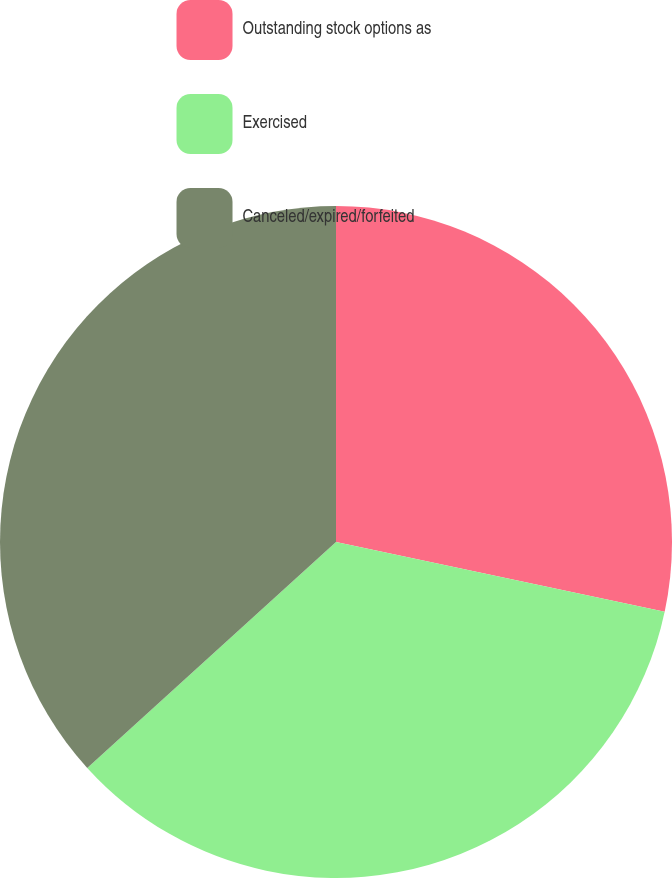<chart> <loc_0><loc_0><loc_500><loc_500><pie_chart><fcel>Outstanding stock options as<fcel>Exercised<fcel>Canceled/expired/forfeited<nl><fcel>28.33%<fcel>34.93%<fcel>36.73%<nl></chart> 